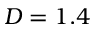<formula> <loc_0><loc_0><loc_500><loc_500>D = 1 . 4</formula> 